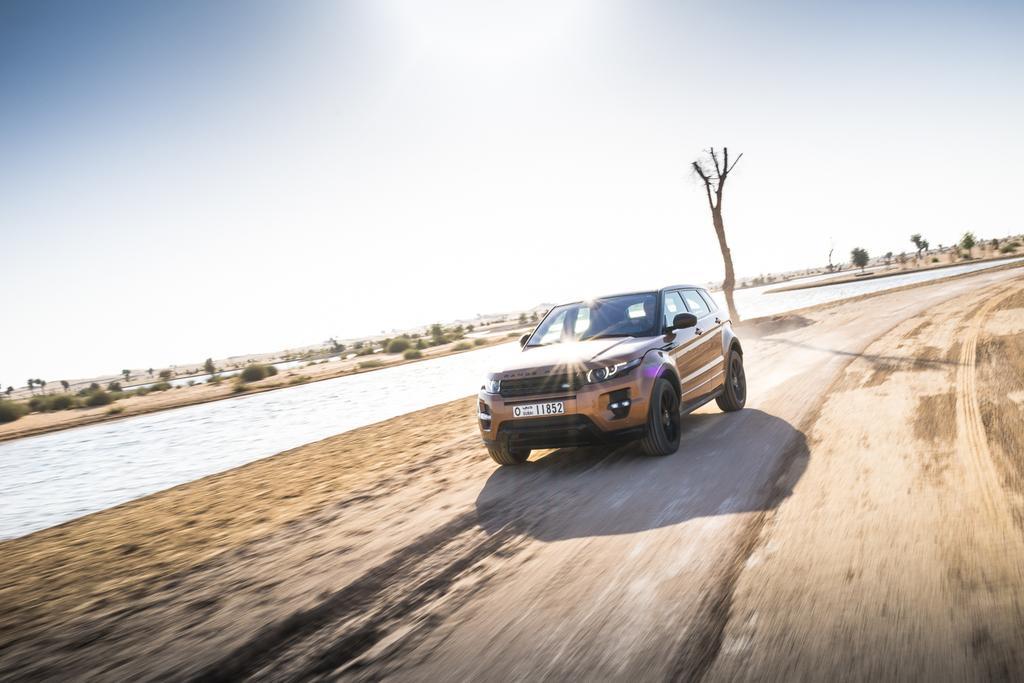Describe this image in one or two sentences. In this picture we can see a car on the path. We can see water. There are a few bushes and trees in the background. We can see the sky on top of the picture. 